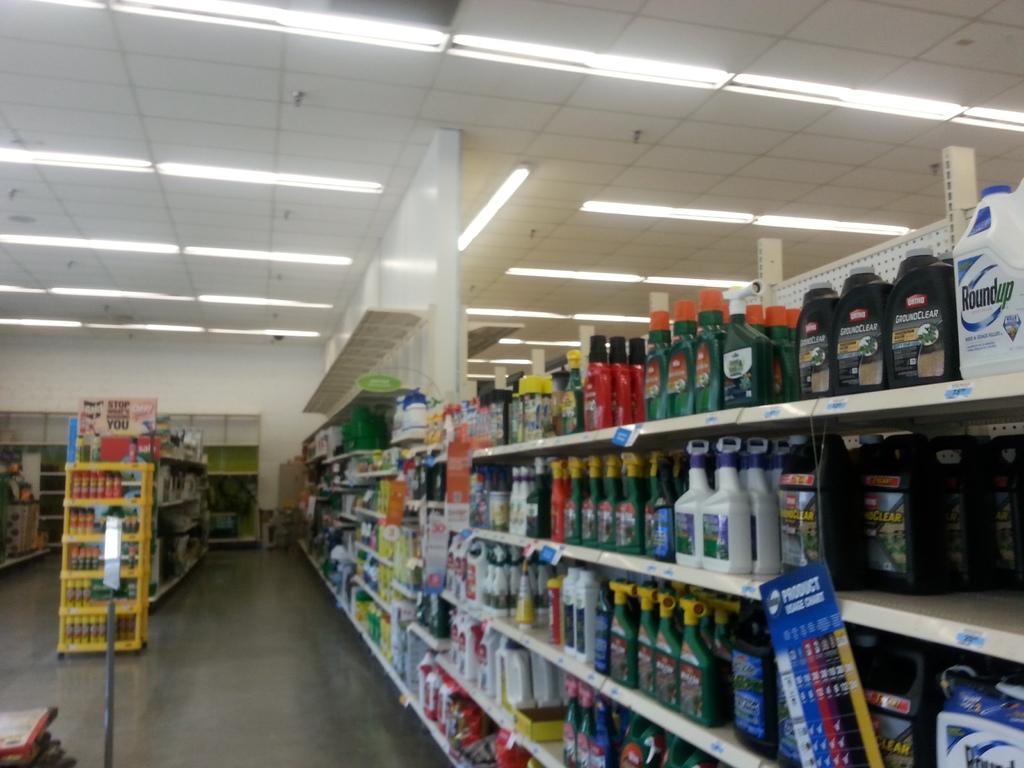What is in the white bottle?
Provide a short and direct response. Roundup. What is written on the sign hanging on the shelf?
Your response must be concise. Product usage chart. 